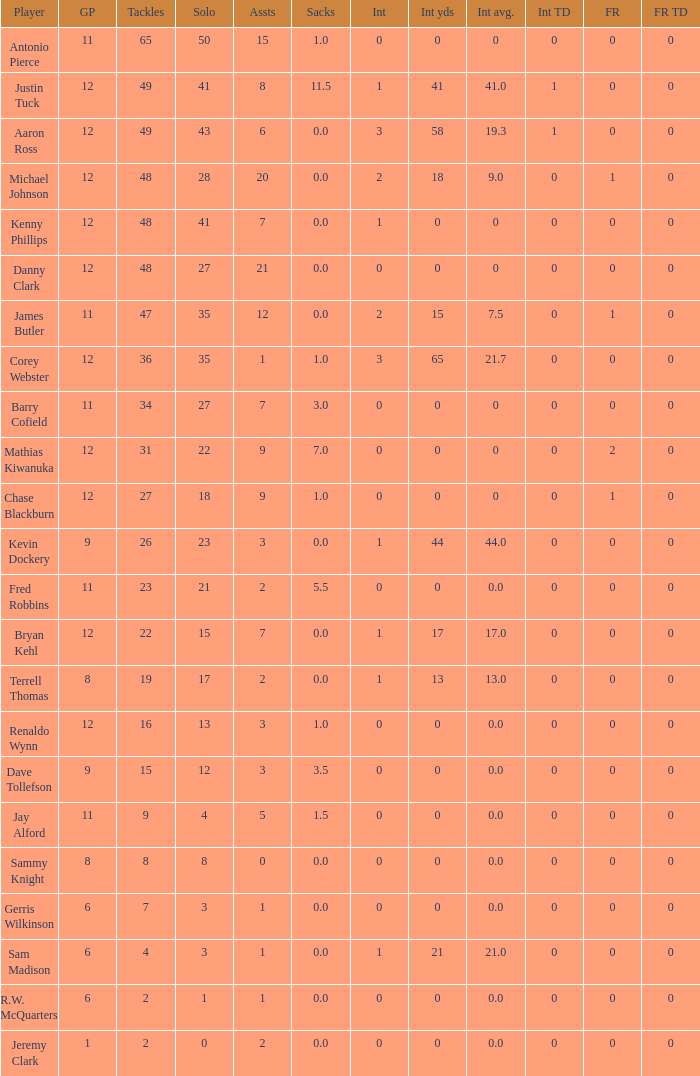Name the least fum rec td 0.0. 